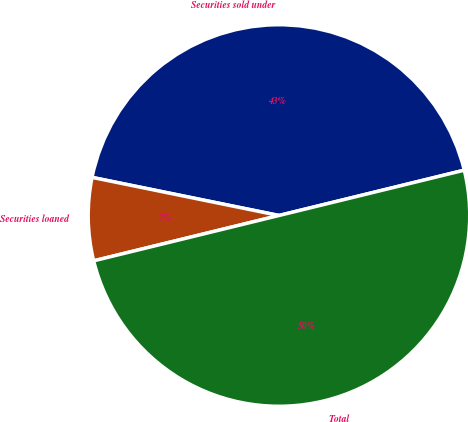<chart> <loc_0><loc_0><loc_500><loc_500><pie_chart><fcel>Securities sold under<fcel>Securities loaned<fcel>Total<nl><fcel>42.98%<fcel>7.02%<fcel>50.0%<nl></chart> 